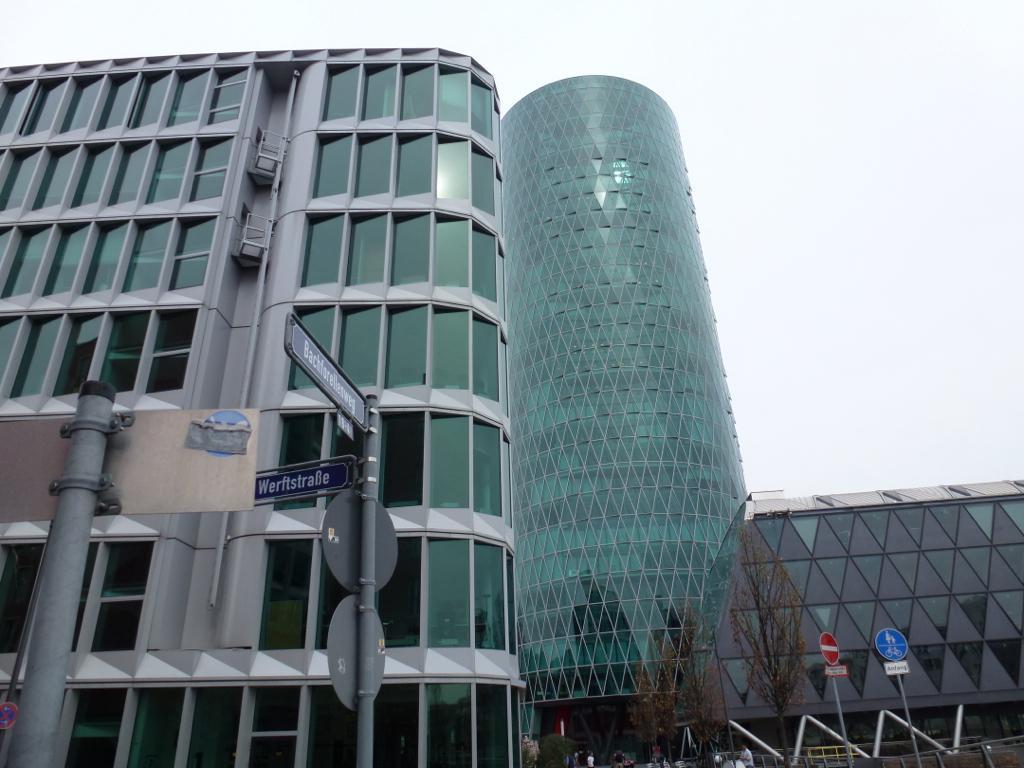Can you describe this image briefly? In this image there is the sky towards the top of the image, there are buildings, there are trees, there are poles towards the bottom of the image, there are boards, there is text on the boards, there is a man towards the bottom of the image. 